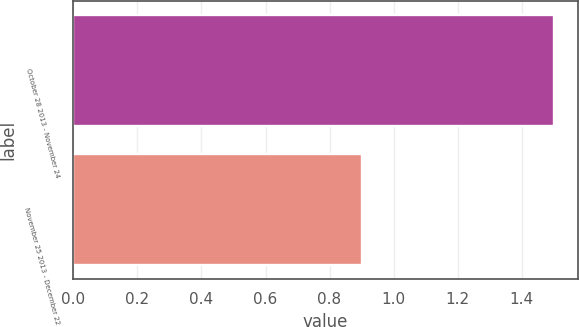Convert chart. <chart><loc_0><loc_0><loc_500><loc_500><bar_chart><fcel>October 28 2013 - November 24<fcel>November 25 2013 - December 22<nl><fcel>1.5<fcel>0.9<nl></chart> 